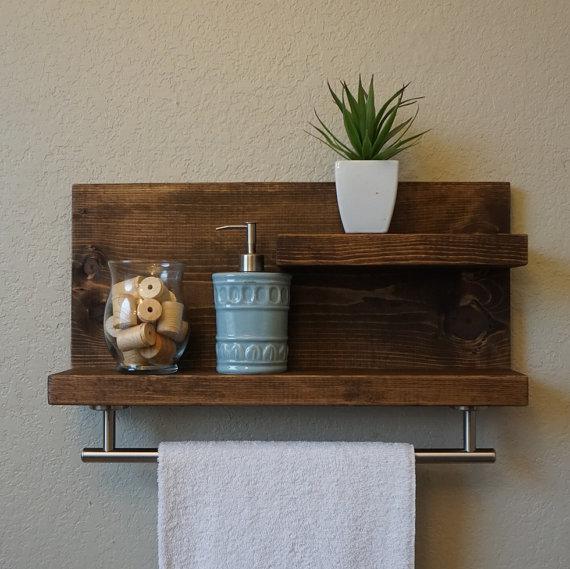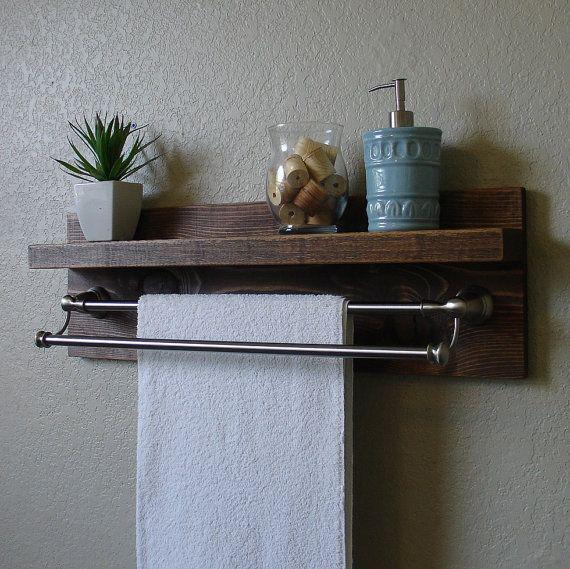The first image is the image on the left, the second image is the image on the right. Analyze the images presented: Is the assertion "All wooden bathroom shelves are stained dark and open on both ends, with no side enclosure boards." valid? Answer yes or no. Yes. 